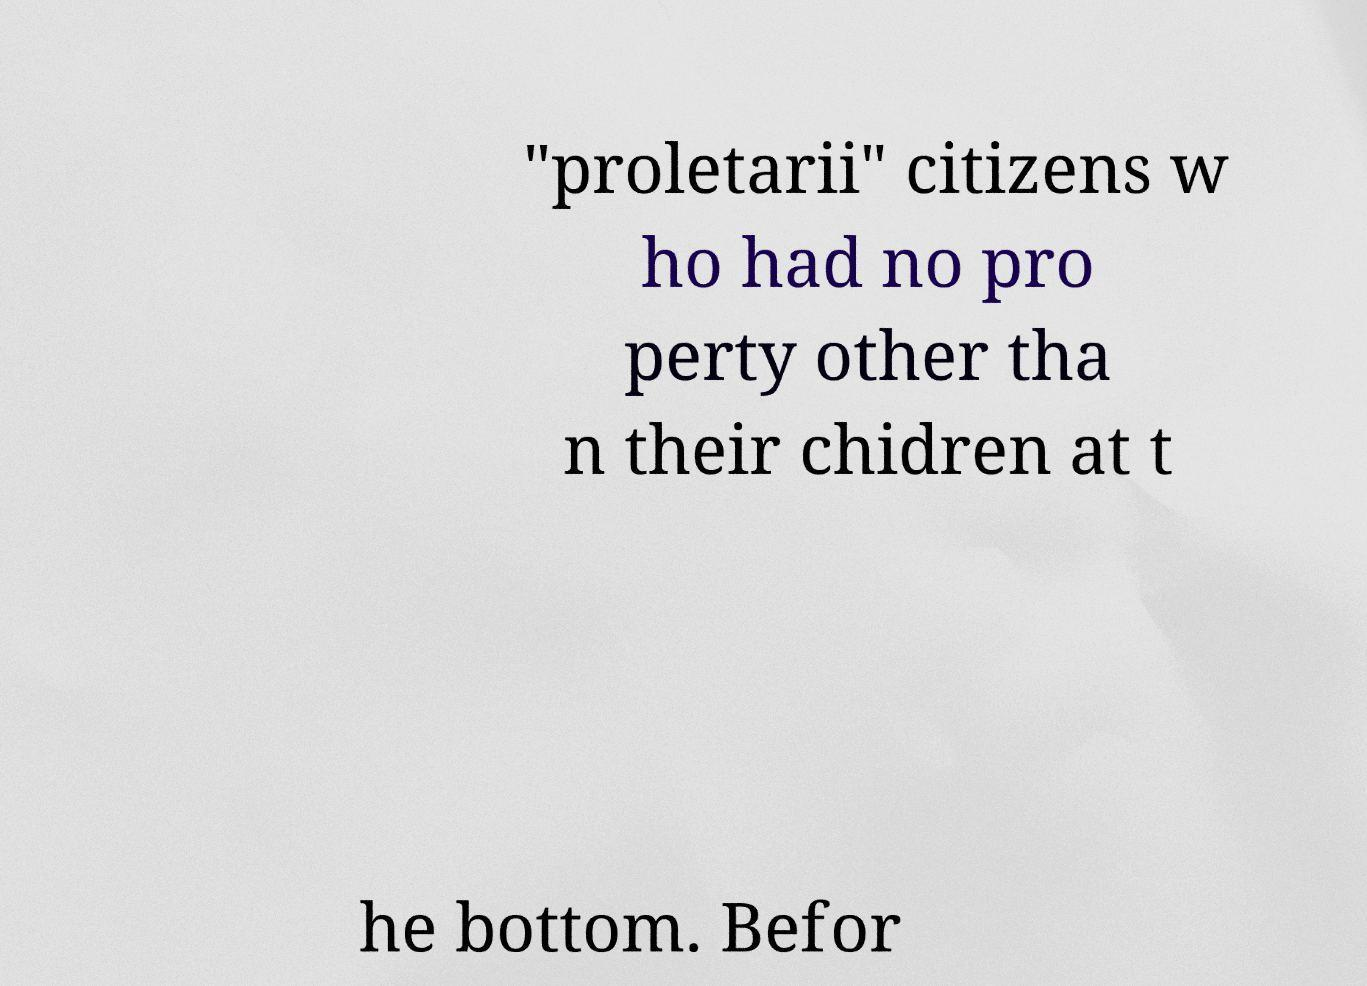Please identify and transcribe the text found in this image. "proletarii" citizens w ho had no pro perty other tha n their chidren at t he bottom. Befor 